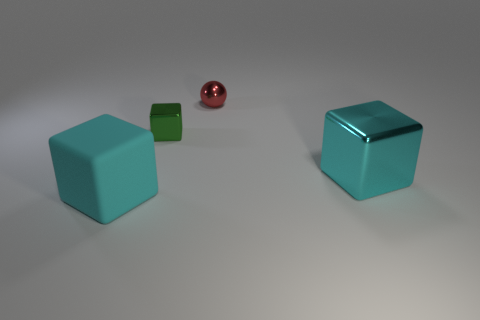How big is the cyan rubber thing?
Keep it short and to the point. Large. What is the size of the cyan object right of the small shiny ball that is behind the big shiny block?
Provide a short and direct response. Large. There is another cyan object that is the same shape as the large metal object; what is it made of?
Provide a succinct answer. Rubber. How many large cubes are there?
Your answer should be very brief. 2. There is a big thing that is on the left side of the big object that is on the right side of the small thing behind the small green shiny cube; what color is it?
Keep it short and to the point. Cyan. Are there fewer small green shiny objects than cyan things?
Your answer should be very brief. Yes. There is a large rubber thing that is the same shape as the tiny green thing; what is its color?
Your answer should be very brief. Cyan. The large object that is the same material as the red ball is what color?
Ensure brevity in your answer.  Cyan. How many metal cubes are the same size as the metal sphere?
Your answer should be compact. 1. Is the number of small things greater than the number of small cyan rubber cylinders?
Ensure brevity in your answer.  Yes. 